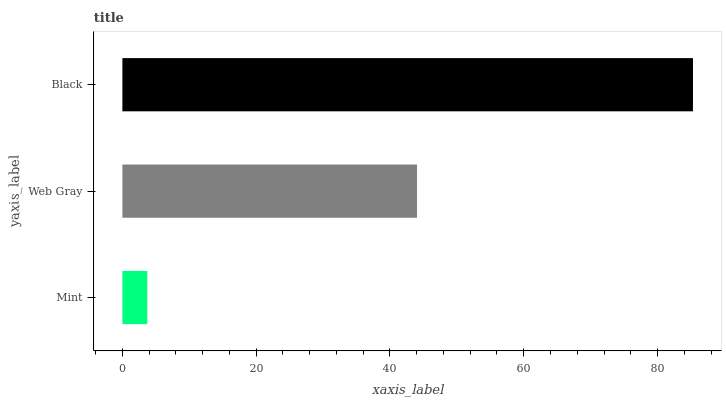Is Mint the minimum?
Answer yes or no. Yes. Is Black the maximum?
Answer yes or no. Yes. Is Web Gray the minimum?
Answer yes or no. No. Is Web Gray the maximum?
Answer yes or no. No. Is Web Gray greater than Mint?
Answer yes or no. Yes. Is Mint less than Web Gray?
Answer yes or no. Yes. Is Mint greater than Web Gray?
Answer yes or no. No. Is Web Gray less than Mint?
Answer yes or no. No. Is Web Gray the high median?
Answer yes or no. Yes. Is Web Gray the low median?
Answer yes or no. Yes. Is Black the high median?
Answer yes or no. No. Is Black the low median?
Answer yes or no. No. 